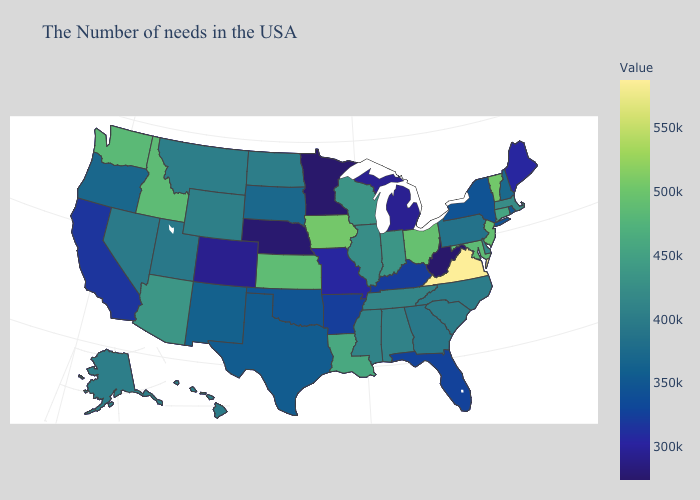Which states have the lowest value in the West?
Quick response, please. Colorado. Does Maryland have the lowest value in the South?
Short answer required. No. Which states have the lowest value in the MidWest?
Short answer required. Minnesota. Does the map have missing data?
Give a very brief answer. No. Does Indiana have a lower value than Missouri?
Concise answer only. No. Which states have the highest value in the USA?
Be succinct. Virginia. Does Maine have the lowest value in the Northeast?
Be succinct. Yes. Does Vermont have the highest value in the Northeast?
Give a very brief answer. Yes. 